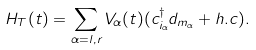Convert formula to latex. <formula><loc_0><loc_0><loc_500><loc_500>H _ { T } ( t ) = \sum _ { \alpha = l , r } V _ { \alpha } ( t ) ( c _ { i _ { \alpha } } ^ { \dagger } d _ { m _ { \alpha } } + h . c ) .</formula> 